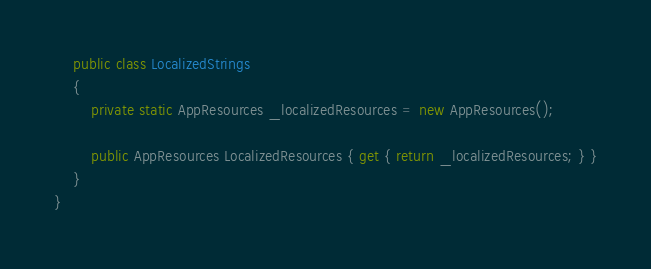<code> <loc_0><loc_0><loc_500><loc_500><_C#_>	public class LocalizedStrings
	{
		private static AppResources _localizedResources = new AppResources();

		public AppResources LocalizedResources { get { return _localizedResources; } }
	}
}
</code> 